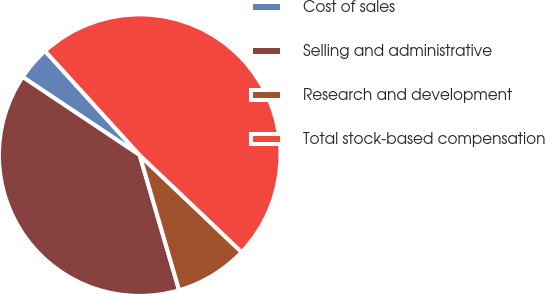Convert chart to OTSL. <chart><loc_0><loc_0><loc_500><loc_500><pie_chart><fcel>Cost of sales<fcel>Selling and administrative<fcel>Research and development<fcel>Total stock-based compensation<nl><fcel>3.89%<fcel>38.89%<fcel>8.38%<fcel>48.84%<nl></chart> 